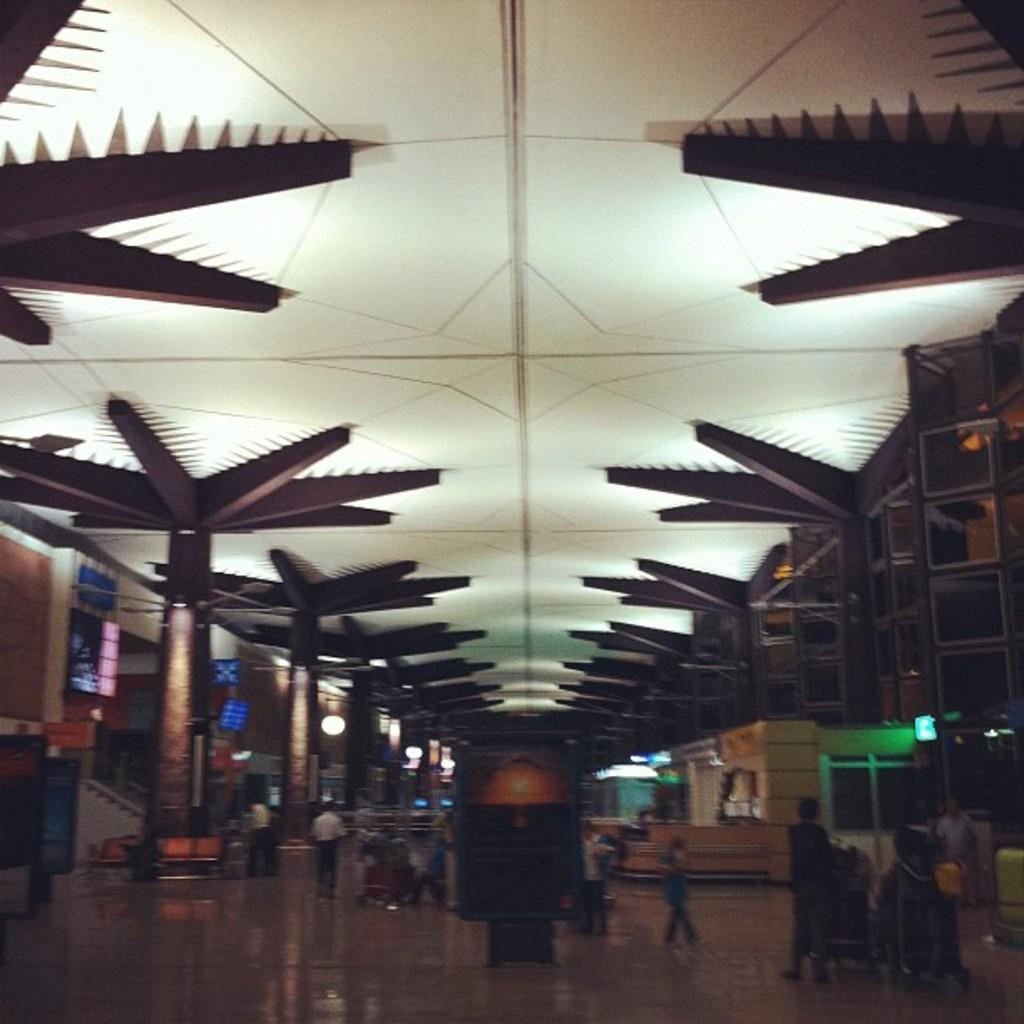What are the people in the image doing? The people in the image are walking. On what surface are the people walking? The people are walking on the floor. What can be seen in the background of the image? In the background of the image, there are boards, pillars, lights, and a different ceiling design. Can you tell me how many receipts are visible on the floor in the image? There are no receipts visible on the floor in the image. What type of fowl can be seen flying in the background of the image? There are no fowl visible in the image, neither on the floor nor in the background. 